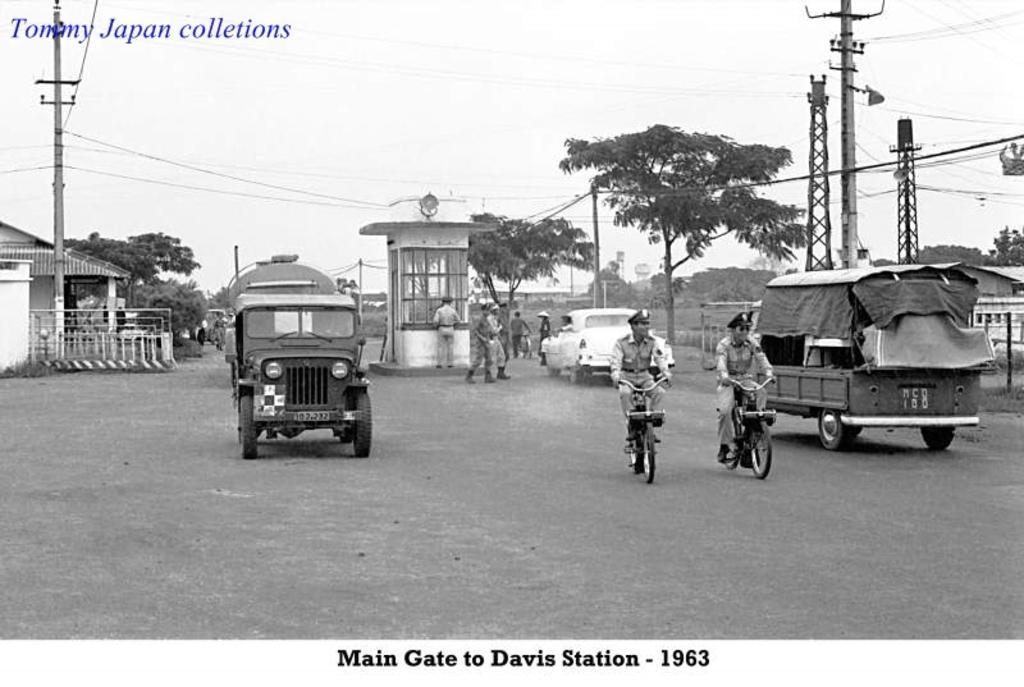In one or two sentences, can you explain what this image depicts? In this image in the center there are vehicles on the road and there are persons riding a bicycle. In the background there are trees, there are persons standing and walking, there are poles and there are wires attached to the poles and there are buildings and there is a fence on the left side. 